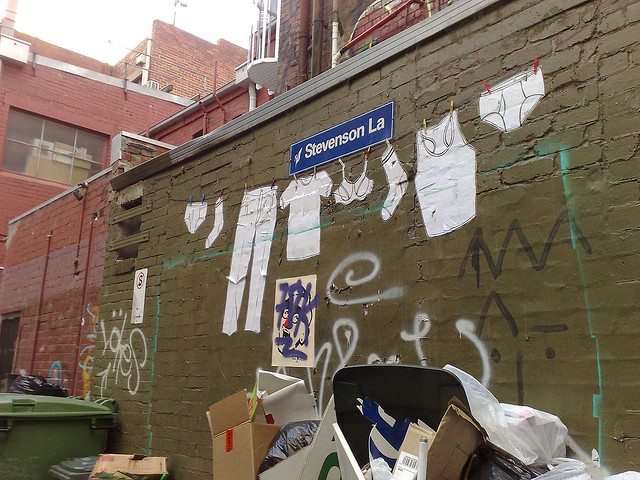Please extract the text content from this image. stevenson La 